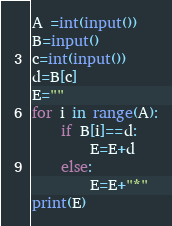<code> <loc_0><loc_0><loc_500><loc_500><_Python_>A =int(input())
B=input()
c=int(input())
d=B[c]
E=""
for i in range(A):
    if B[i]==d:
        E=E+d
    else:
        E=E+"*"
print(E)</code> 